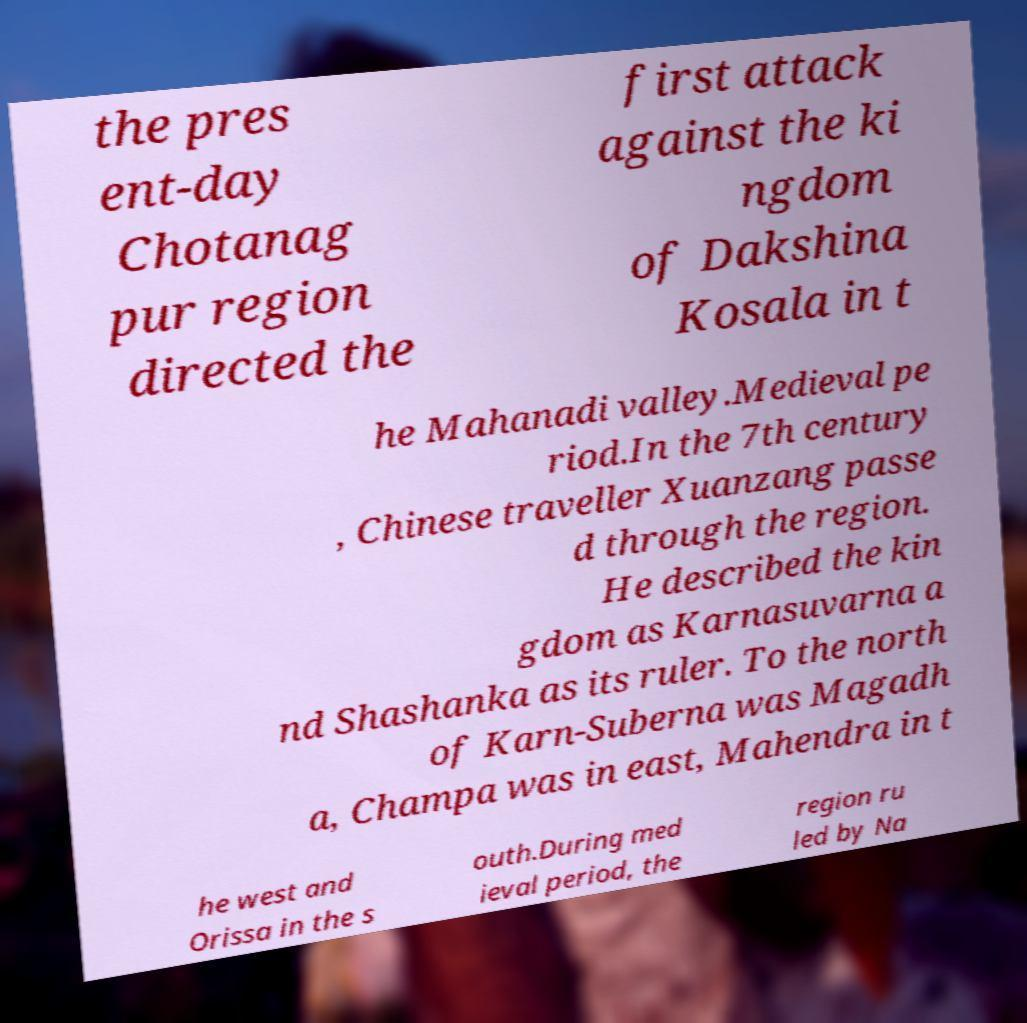Could you assist in decoding the text presented in this image and type it out clearly? the pres ent-day Chotanag pur region directed the first attack against the ki ngdom of Dakshina Kosala in t he Mahanadi valley.Medieval pe riod.In the 7th century , Chinese traveller Xuanzang passe d through the region. He described the kin gdom as Karnasuvarna a nd Shashanka as its ruler. To the north of Karn-Suberna was Magadh a, Champa was in east, Mahendra in t he west and Orissa in the s outh.During med ieval period, the region ru led by Na 